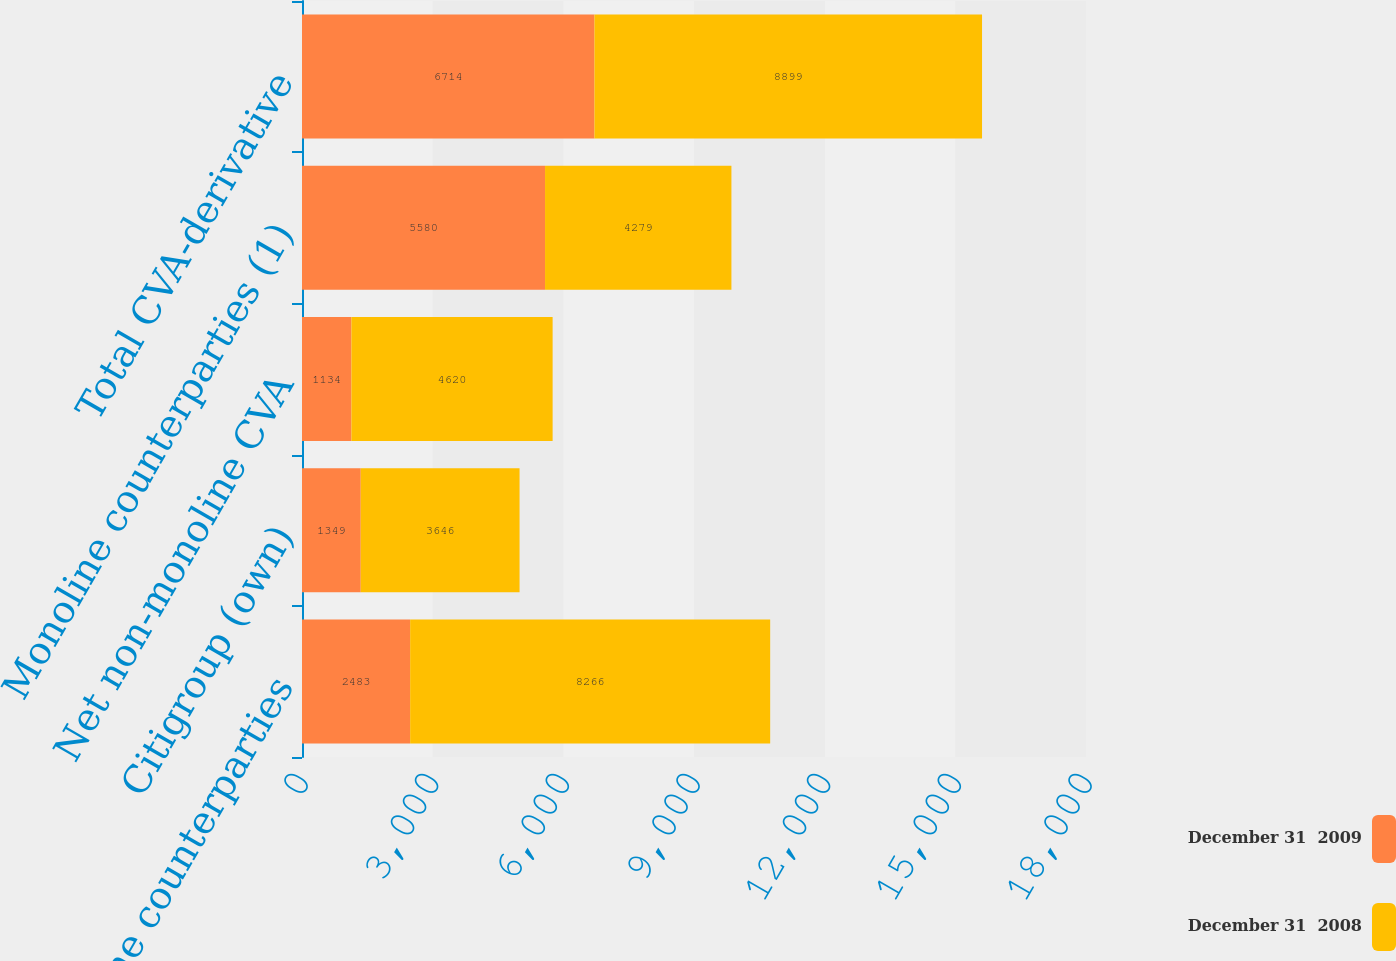<chart> <loc_0><loc_0><loc_500><loc_500><stacked_bar_chart><ecel><fcel>Non-monoline counterparties<fcel>Citigroup (own)<fcel>Net non-monoline CVA<fcel>Monoline counterparties (1)<fcel>Total CVA-derivative<nl><fcel>December 31  2009<fcel>2483<fcel>1349<fcel>1134<fcel>5580<fcel>6714<nl><fcel>December 31  2008<fcel>8266<fcel>3646<fcel>4620<fcel>4279<fcel>8899<nl></chart> 